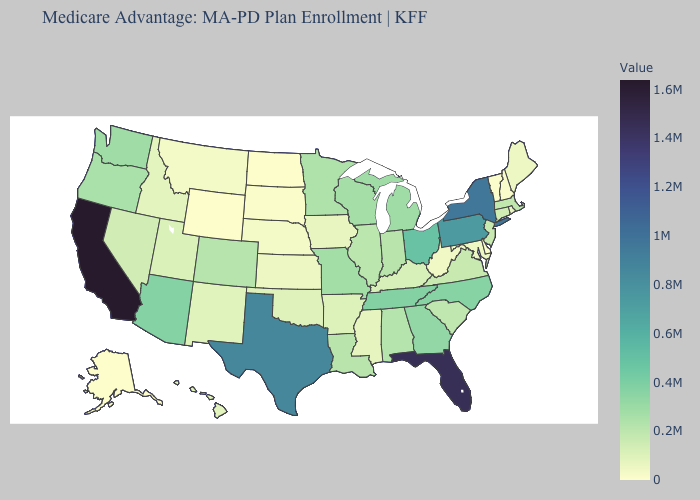Does Missouri have the lowest value in the MidWest?
Be succinct. No. Does Delaware have a lower value than Wisconsin?
Give a very brief answer. Yes. Among the states that border North Dakota , does Montana have the highest value?
Quick response, please. No. Does California have a lower value than Idaho?
Write a very short answer. No. Does Minnesota have the lowest value in the MidWest?
Write a very short answer. No. Does Indiana have the highest value in the MidWest?
Short answer required. No. Does California have the highest value in the USA?
Be succinct. Yes. 